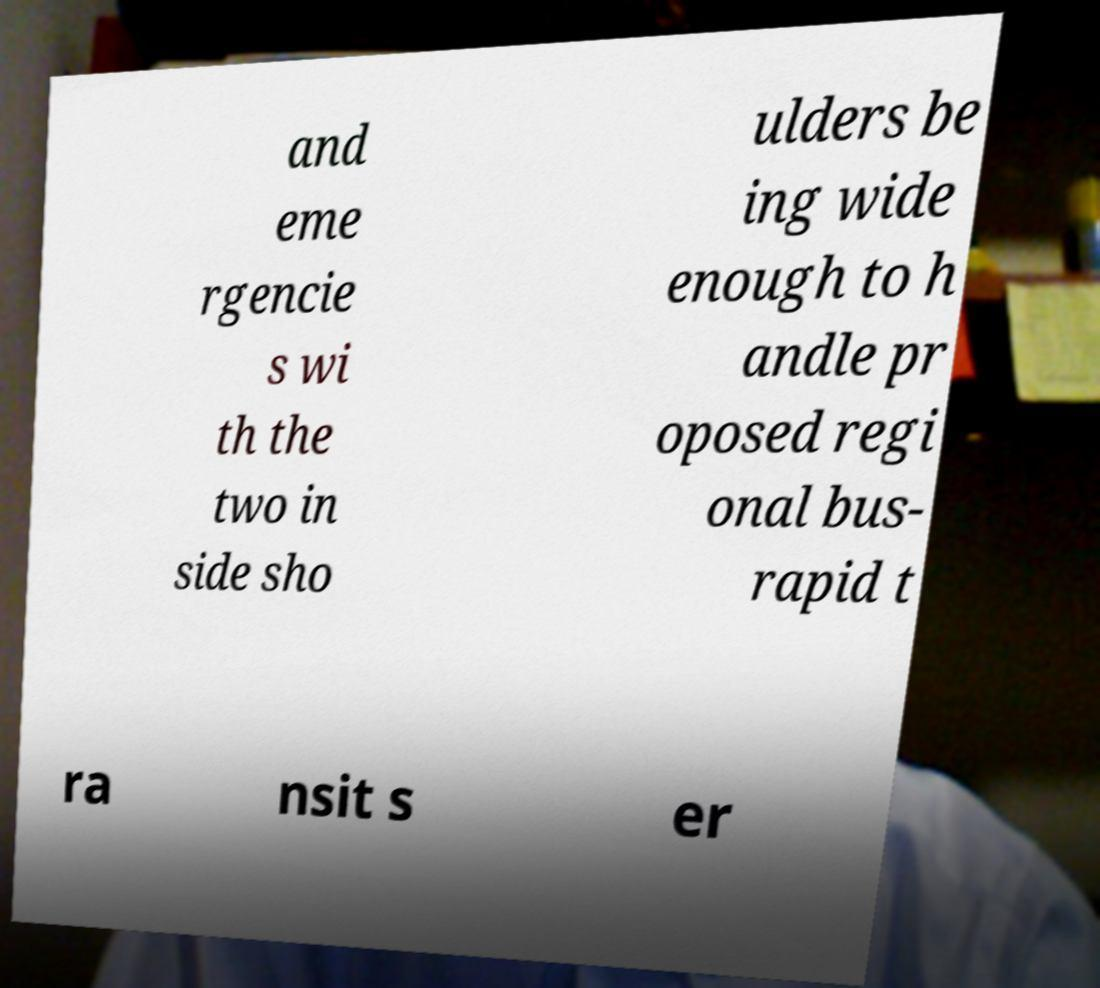Please read and relay the text visible in this image. What does it say? and eme rgencie s wi th the two in side sho ulders be ing wide enough to h andle pr oposed regi onal bus- rapid t ra nsit s er 